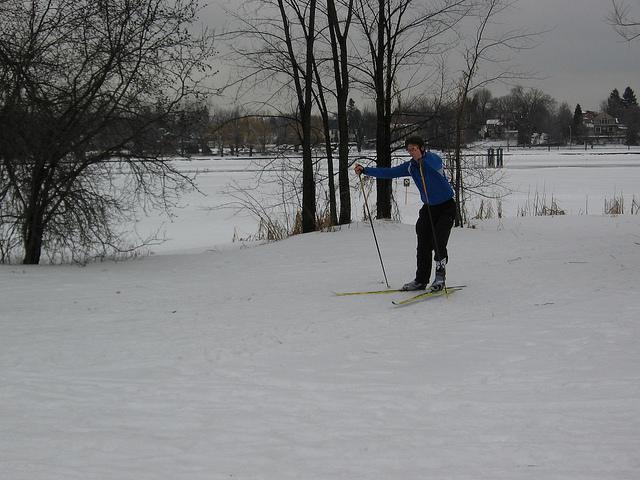How many people are in this image?
Give a very brief answer. 1. 